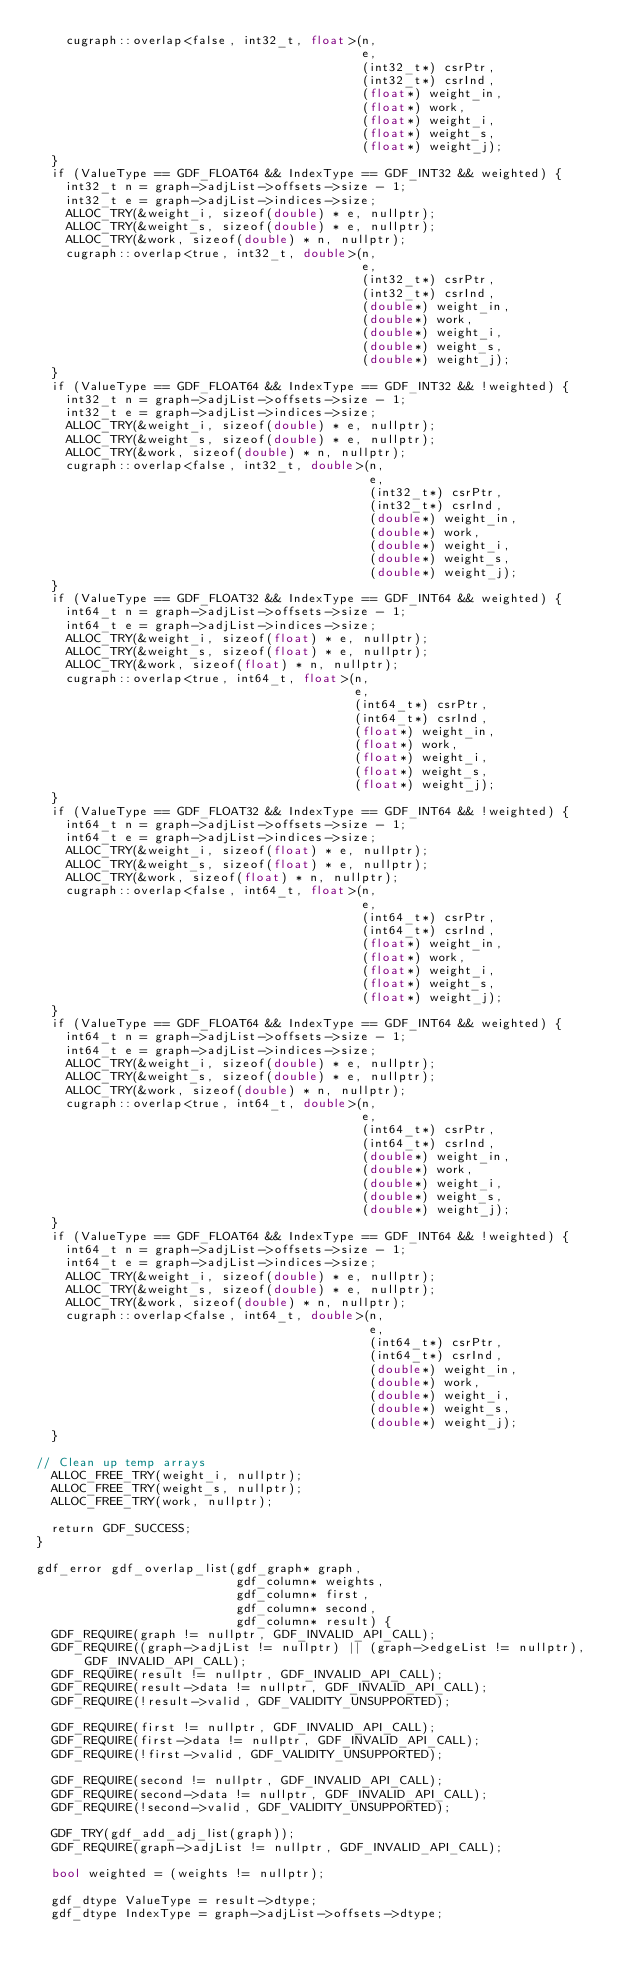<code> <loc_0><loc_0><loc_500><loc_500><_Cuda_>    cugraph::overlap<false, int32_t, float>(n,
                                            e,
                                            (int32_t*) csrPtr,
                                            (int32_t*) csrInd,
                                            (float*) weight_in,
                                            (float*) work,
                                            (float*) weight_i,
                                            (float*) weight_s,
                                            (float*) weight_j);
  }
  if (ValueType == GDF_FLOAT64 && IndexType == GDF_INT32 && weighted) {
    int32_t n = graph->adjList->offsets->size - 1;
    int32_t e = graph->adjList->indices->size;
    ALLOC_TRY(&weight_i, sizeof(double) * e, nullptr);
    ALLOC_TRY(&weight_s, sizeof(double) * e, nullptr);
    ALLOC_TRY(&work, sizeof(double) * n, nullptr);
    cugraph::overlap<true, int32_t, double>(n,
                                            e,
                                            (int32_t*) csrPtr,
                                            (int32_t*) csrInd,
                                            (double*) weight_in,
                                            (double*) work,
                                            (double*) weight_i,
                                            (double*) weight_s,
                                            (double*) weight_j);
  }
  if (ValueType == GDF_FLOAT64 && IndexType == GDF_INT32 && !weighted) {
    int32_t n = graph->adjList->offsets->size - 1;
    int32_t e = graph->adjList->indices->size;
    ALLOC_TRY(&weight_i, sizeof(double) * e, nullptr);
    ALLOC_TRY(&weight_s, sizeof(double) * e, nullptr);
    ALLOC_TRY(&work, sizeof(double) * n, nullptr);
    cugraph::overlap<false, int32_t, double>(n,
                                             e,
                                             (int32_t*) csrPtr,
                                             (int32_t*) csrInd,
                                             (double*) weight_in,
                                             (double*) work,
                                             (double*) weight_i,
                                             (double*) weight_s,
                                             (double*) weight_j);
  }
  if (ValueType == GDF_FLOAT32 && IndexType == GDF_INT64 && weighted) {
    int64_t n = graph->adjList->offsets->size - 1;
    int64_t e = graph->adjList->indices->size;
    ALLOC_TRY(&weight_i, sizeof(float) * e, nullptr);
    ALLOC_TRY(&weight_s, sizeof(float) * e, nullptr);
    ALLOC_TRY(&work, sizeof(float) * n, nullptr);
    cugraph::overlap<true, int64_t, float>(n,
                                           e,
                                           (int64_t*) csrPtr,
                                           (int64_t*) csrInd,
                                           (float*) weight_in,
                                           (float*) work,
                                           (float*) weight_i,
                                           (float*) weight_s,
                                           (float*) weight_j);
  }
  if (ValueType == GDF_FLOAT32 && IndexType == GDF_INT64 && !weighted) {
    int64_t n = graph->adjList->offsets->size - 1;
    int64_t e = graph->adjList->indices->size;
    ALLOC_TRY(&weight_i, sizeof(float) * e, nullptr);
    ALLOC_TRY(&weight_s, sizeof(float) * e, nullptr);
    ALLOC_TRY(&work, sizeof(float) * n, nullptr);
    cugraph::overlap<false, int64_t, float>(n,
                                            e,
                                            (int64_t*) csrPtr,
                                            (int64_t*) csrInd,
                                            (float*) weight_in,
                                            (float*) work,
                                            (float*) weight_i,
                                            (float*) weight_s,
                                            (float*) weight_j);
  }
  if (ValueType == GDF_FLOAT64 && IndexType == GDF_INT64 && weighted) {
    int64_t n = graph->adjList->offsets->size - 1;
    int64_t e = graph->adjList->indices->size;
    ALLOC_TRY(&weight_i, sizeof(double) * e, nullptr);
    ALLOC_TRY(&weight_s, sizeof(double) * e, nullptr);
    ALLOC_TRY(&work, sizeof(double) * n, nullptr);
    cugraph::overlap<true, int64_t, double>(n,
                                            e,
                                            (int64_t*) csrPtr,
                                            (int64_t*) csrInd,
                                            (double*) weight_in,
                                            (double*) work,
                                            (double*) weight_i,
                                            (double*) weight_s,
                                            (double*) weight_j);
  }
  if (ValueType == GDF_FLOAT64 && IndexType == GDF_INT64 && !weighted) {
    int64_t n = graph->adjList->offsets->size - 1;
    int64_t e = graph->adjList->indices->size;
    ALLOC_TRY(&weight_i, sizeof(double) * e, nullptr);
    ALLOC_TRY(&weight_s, sizeof(double) * e, nullptr);
    ALLOC_TRY(&work, sizeof(double) * n, nullptr);
    cugraph::overlap<false, int64_t, double>(n,
                                             e,
                                             (int64_t*) csrPtr,
                                             (int64_t*) csrInd,
                                             (double*) weight_in,
                                             (double*) work,
                                             (double*) weight_i,
                                             (double*) weight_s,
                                             (double*) weight_j);
  }

// Clean up temp arrays
  ALLOC_FREE_TRY(weight_i, nullptr);
  ALLOC_FREE_TRY(weight_s, nullptr);
  ALLOC_FREE_TRY(work, nullptr);

  return GDF_SUCCESS;
}

gdf_error gdf_overlap_list(gdf_graph* graph,
                           gdf_column* weights,
                           gdf_column* first,
                           gdf_column* second,
                           gdf_column* result) {
  GDF_REQUIRE(graph != nullptr, GDF_INVALID_API_CALL);
  GDF_REQUIRE((graph->adjList != nullptr) || (graph->edgeList != nullptr), GDF_INVALID_API_CALL);
  GDF_REQUIRE(result != nullptr, GDF_INVALID_API_CALL);
  GDF_REQUIRE(result->data != nullptr, GDF_INVALID_API_CALL);
  GDF_REQUIRE(!result->valid, GDF_VALIDITY_UNSUPPORTED);

  GDF_REQUIRE(first != nullptr, GDF_INVALID_API_CALL);
  GDF_REQUIRE(first->data != nullptr, GDF_INVALID_API_CALL);
  GDF_REQUIRE(!first->valid, GDF_VALIDITY_UNSUPPORTED);

  GDF_REQUIRE(second != nullptr, GDF_INVALID_API_CALL);
  GDF_REQUIRE(second->data != nullptr, GDF_INVALID_API_CALL);
  GDF_REQUIRE(!second->valid, GDF_VALIDITY_UNSUPPORTED);

  GDF_TRY(gdf_add_adj_list(graph));
  GDF_REQUIRE(graph->adjList != nullptr, GDF_INVALID_API_CALL);

  bool weighted = (weights != nullptr);

  gdf_dtype ValueType = result->dtype;
  gdf_dtype IndexType = graph->adjList->offsets->dtype;</code> 